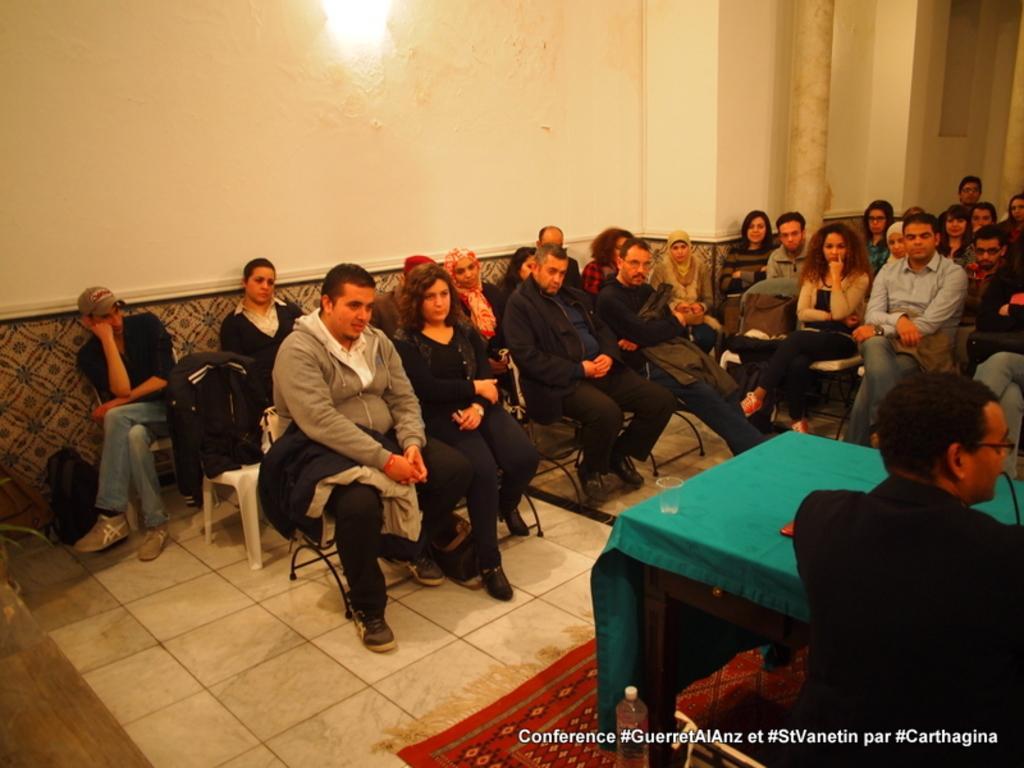Describe this image in one or two sentences. Here we can see few people sitting on the chairs. On the right there is a man sitting on the chair at the table and on the table we can see a transparent glass,microphone and an object. In the background we can see a light on the wall and a there is a pillar over here. 